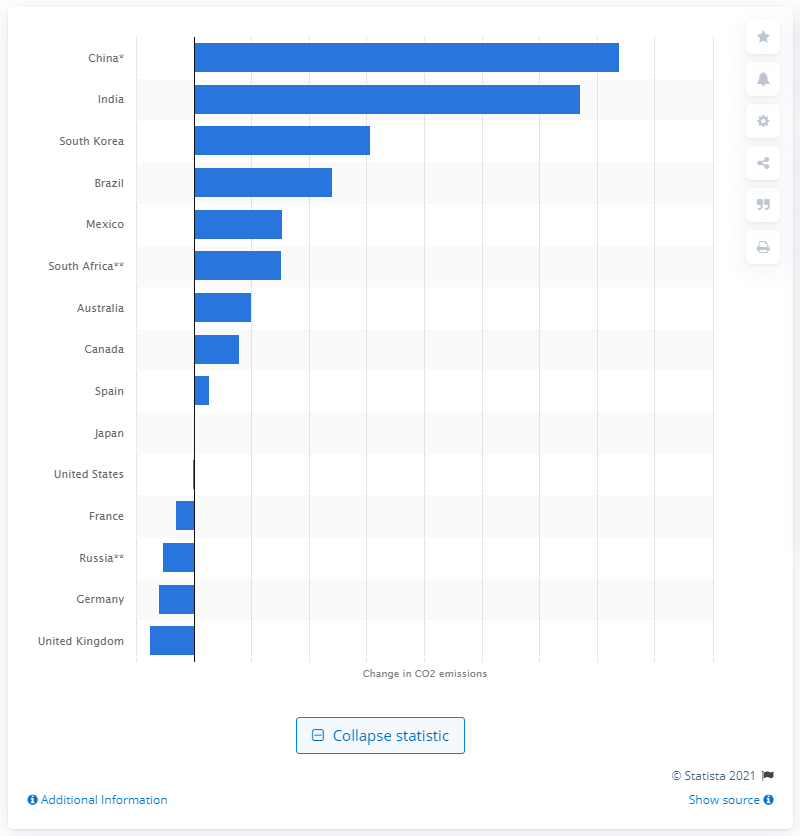Draw attention to some important aspects in this diagram. Emissions in the United States have decreased by 335.59 million metric tons since 1990. Carbon dioxide emissions from fuel combustion in China increased significantly from 1990 to 2019, with a total increase of 369.58%. India's CO2 emissions increased by 335.59% from 1990 to 2019. 